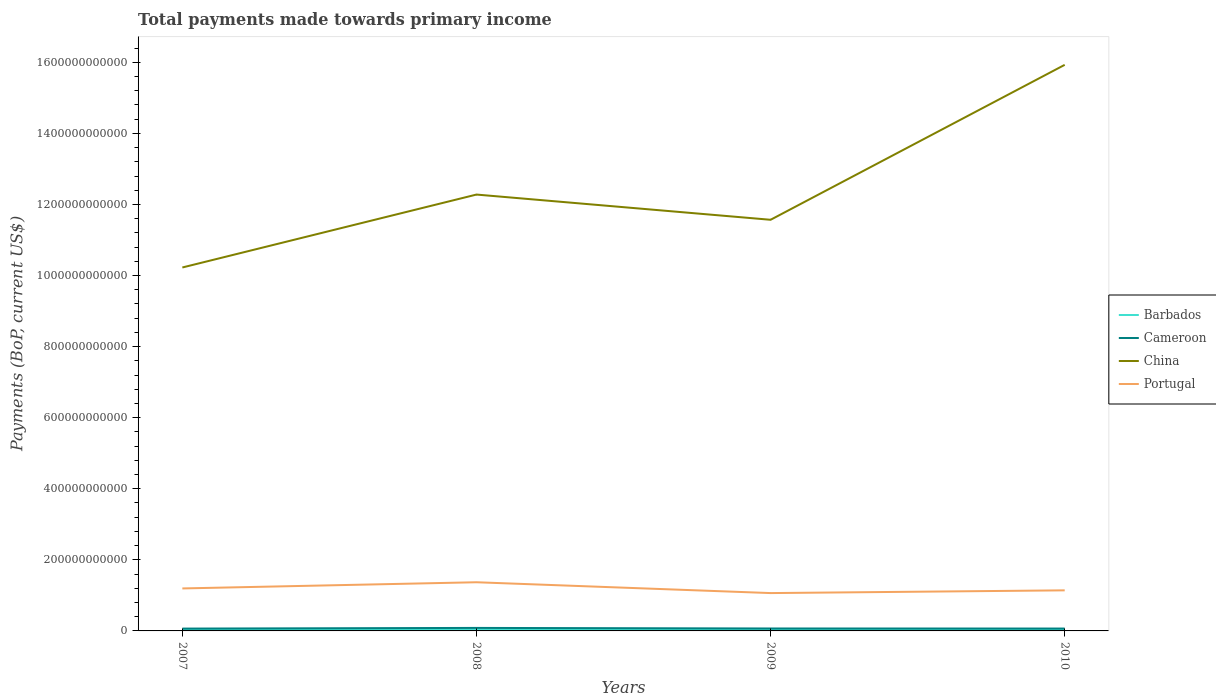How many different coloured lines are there?
Ensure brevity in your answer.  4. Across all years, what is the maximum total payments made towards primary income in Portugal?
Provide a short and direct response. 1.07e+11. In which year was the total payments made towards primary income in China maximum?
Provide a short and direct response. 2007. What is the total total payments made towards primary income in Portugal in the graph?
Provide a succinct answer. -1.74e+1. What is the difference between the highest and the second highest total payments made towards primary income in Portugal?
Give a very brief answer. 3.05e+1. Is the total payments made towards primary income in Portugal strictly greater than the total payments made towards primary income in China over the years?
Make the answer very short. Yes. How many lines are there?
Offer a very short reply. 4. What is the difference between two consecutive major ticks on the Y-axis?
Give a very brief answer. 2.00e+11. Does the graph contain grids?
Give a very brief answer. No. How many legend labels are there?
Offer a terse response. 4. How are the legend labels stacked?
Your response must be concise. Vertical. What is the title of the graph?
Give a very brief answer. Total payments made towards primary income. What is the label or title of the Y-axis?
Give a very brief answer. Payments (BoP, current US$). What is the Payments (BoP, current US$) of Barbados in 2007?
Your answer should be very brief. 2.76e+09. What is the Payments (BoP, current US$) of Cameroon in 2007?
Your answer should be compact. 6.55e+09. What is the Payments (BoP, current US$) of China in 2007?
Provide a short and direct response. 1.02e+12. What is the Payments (BoP, current US$) of Portugal in 2007?
Your response must be concise. 1.20e+11. What is the Payments (BoP, current US$) in Barbados in 2008?
Provide a succinct answer. 2.99e+09. What is the Payments (BoP, current US$) in Cameroon in 2008?
Ensure brevity in your answer.  8.44e+09. What is the Payments (BoP, current US$) of China in 2008?
Offer a terse response. 1.23e+12. What is the Payments (BoP, current US$) in Portugal in 2008?
Ensure brevity in your answer.  1.37e+11. What is the Payments (BoP, current US$) in Barbados in 2009?
Your answer should be compact. 2.54e+09. What is the Payments (BoP, current US$) in Cameroon in 2009?
Your answer should be very brief. 6.84e+09. What is the Payments (BoP, current US$) in China in 2009?
Provide a succinct answer. 1.16e+12. What is the Payments (BoP, current US$) in Portugal in 2009?
Keep it short and to the point. 1.07e+11. What is the Payments (BoP, current US$) in Barbados in 2010?
Your answer should be compact. 2.59e+09. What is the Payments (BoP, current US$) of Cameroon in 2010?
Your answer should be compact. 6.70e+09. What is the Payments (BoP, current US$) of China in 2010?
Offer a terse response. 1.59e+12. What is the Payments (BoP, current US$) in Portugal in 2010?
Provide a short and direct response. 1.14e+11. Across all years, what is the maximum Payments (BoP, current US$) in Barbados?
Offer a terse response. 2.99e+09. Across all years, what is the maximum Payments (BoP, current US$) of Cameroon?
Make the answer very short. 8.44e+09. Across all years, what is the maximum Payments (BoP, current US$) in China?
Your answer should be compact. 1.59e+12. Across all years, what is the maximum Payments (BoP, current US$) in Portugal?
Your response must be concise. 1.37e+11. Across all years, what is the minimum Payments (BoP, current US$) of Barbados?
Your response must be concise. 2.54e+09. Across all years, what is the minimum Payments (BoP, current US$) in Cameroon?
Provide a short and direct response. 6.55e+09. Across all years, what is the minimum Payments (BoP, current US$) in China?
Your answer should be very brief. 1.02e+12. Across all years, what is the minimum Payments (BoP, current US$) in Portugal?
Provide a short and direct response. 1.07e+11. What is the total Payments (BoP, current US$) in Barbados in the graph?
Make the answer very short. 1.09e+1. What is the total Payments (BoP, current US$) in Cameroon in the graph?
Make the answer very short. 2.85e+1. What is the total Payments (BoP, current US$) of China in the graph?
Provide a short and direct response. 5.00e+12. What is the total Payments (BoP, current US$) in Portugal in the graph?
Ensure brevity in your answer.  4.77e+11. What is the difference between the Payments (BoP, current US$) of Barbados in 2007 and that in 2008?
Your answer should be very brief. -2.37e+08. What is the difference between the Payments (BoP, current US$) of Cameroon in 2007 and that in 2008?
Offer a terse response. -1.89e+09. What is the difference between the Payments (BoP, current US$) of China in 2007 and that in 2008?
Make the answer very short. -2.05e+11. What is the difference between the Payments (BoP, current US$) of Portugal in 2007 and that in 2008?
Your answer should be compact. -1.74e+1. What is the difference between the Payments (BoP, current US$) of Barbados in 2007 and that in 2009?
Keep it short and to the point. 2.16e+08. What is the difference between the Payments (BoP, current US$) in Cameroon in 2007 and that in 2009?
Your answer should be compact. -2.90e+08. What is the difference between the Payments (BoP, current US$) of China in 2007 and that in 2009?
Give a very brief answer. -1.34e+11. What is the difference between the Payments (BoP, current US$) in Portugal in 2007 and that in 2009?
Your answer should be very brief. 1.31e+1. What is the difference between the Payments (BoP, current US$) of Barbados in 2007 and that in 2010?
Your answer should be compact. 1.68e+08. What is the difference between the Payments (BoP, current US$) of Cameroon in 2007 and that in 2010?
Ensure brevity in your answer.  -1.51e+08. What is the difference between the Payments (BoP, current US$) in China in 2007 and that in 2010?
Make the answer very short. -5.70e+11. What is the difference between the Payments (BoP, current US$) of Portugal in 2007 and that in 2010?
Ensure brevity in your answer.  5.39e+09. What is the difference between the Payments (BoP, current US$) in Barbados in 2008 and that in 2009?
Your answer should be very brief. 4.53e+08. What is the difference between the Payments (BoP, current US$) in Cameroon in 2008 and that in 2009?
Provide a short and direct response. 1.60e+09. What is the difference between the Payments (BoP, current US$) of China in 2008 and that in 2009?
Offer a terse response. 7.10e+1. What is the difference between the Payments (BoP, current US$) in Portugal in 2008 and that in 2009?
Keep it short and to the point. 3.05e+1. What is the difference between the Payments (BoP, current US$) of Barbados in 2008 and that in 2010?
Offer a very short reply. 4.05e+08. What is the difference between the Payments (BoP, current US$) in Cameroon in 2008 and that in 2010?
Keep it short and to the point. 1.74e+09. What is the difference between the Payments (BoP, current US$) of China in 2008 and that in 2010?
Provide a succinct answer. -3.65e+11. What is the difference between the Payments (BoP, current US$) in Portugal in 2008 and that in 2010?
Provide a short and direct response. 2.28e+1. What is the difference between the Payments (BoP, current US$) in Barbados in 2009 and that in 2010?
Make the answer very short. -4.80e+07. What is the difference between the Payments (BoP, current US$) in Cameroon in 2009 and that in 2010?
Make the answer very short. 1.39e+08. What is the difference between the Payments (BoP, current US$) in China in 2009 and that in 2010?
Give a very brief answer. -4.36e+11. What is the difference between the Payments (BoP, current US$) of Portugal in 2009 and that in 2010?
Ensure brevity in your answer.  -7.67e+09. What is the difference between the Payments (BoP, current US$) in Barbados in 2007 and the Payments (BoP, current US$) in Cameroon in 2008?
Offer a very short reply. -5.68e+09. What is the difference between the Payments (BoP, current US$) of Barbados in 2007 and the Payments (BoP, current US$) of China in 2008?
Offer a terse response. -1.23e+12. What is the difference between the Payments (BoP, current US$) of Barbados in 2007 and the Payments (BoP, current US$) of Portugal in 2008?
Your answer should be compact. -1.34e+11. What is the difference between the Payments (BoP, current US$) in Cameroon in 2007 and the Payments (BoP, current US$) in China in 2008?
Give a very brief answer. -1.22e+12. What is the difference between the Payments (BoP, current US$) in Cameroon in 2007 and the Payments (BoP, current US$) in Portugal in 2008?
Your answer should be very brief. -1.30e+11. What is the difference between the Payments (BoP, current US$) in China in 2007 and the Payments (BoP, current US$) in Portugal in 2008?
Offer a terse response. 8.86e+11. What is the difference between the Payments (BoP, current US$) in Barbados in 2007 and the Payments (BoP, current US$) in Cameroon in 2009?
Your answer should be very brief. -4.09e+09. What is the difference between the Payments (BoP, current US$) in Barbados in 2007 and the Payments (BoP, current US$) in China in 2009?
Offer a very short reply. -1.15e+12. What is the difference between the Payments (BoP, current US$) in Barbados in 2007 and the Payments (BoP, current US$) in Portugal in 2009?
Provide a succinct answer. -1.04e+11. What is the difference between the Payments (BoP, current US$) in Cameroon in 2007 and the Payments (BoP, current US$) in China in 2009?
Your answer should be compact. -1.15e+12. What is the difference between the Payments (BoP, current US$) of Cameroon in 2007 and the Payments (BoP, current US$) of Portugal in 2009?
Provide a succinct answer. -9.99e+1. What is the difference between the Payments (BoP, current US$) of China in 2007 and the Payments (BoP, current US$) of Portugal in 2009?
Provide a succinct answer. 9.16e+11. What is the difference between the Payments (BoP, current US$) in Barbados in 2007 and the Payments (BoP, current US$) in Cameroon in 2010?
Your answer should be compact. -3.95e+09. What is the difference between the Payments (BoP, current US$) in Barbados in 2007 and the Payments (BoP, current US$) in China in 2010?
Give a very brief answer. -1.59e+12. What is the difference between the Payments (BoP, current US$) in Barbados in 2007 and the Payments (BoP, current US$) in Portugal in 2010?
Make the answer very short. -1.11e+11. What is the difference between the Payments (BoP, current US$) in Cameroon in 2007 and the Payments (BoP, current US$) in China in 2010?
Offer a very short reply. -1.59e+12. What is the difference between the Payments (BoP, current US$) in Cameroon in 2007 and the Payments (BoP, current US$) in Portugal in 2010?
Provide a short and direct response. -1.08e+11. What is the difference between the Payments (BoP, current US$) of China in 2007 and the Payments (BoP, current US$) of Portugal in 2010?
Your answer should be very brief. 9.09e+11. What is the difference between the Payments (BoP, current US$) of Barbados in 2008 and the Payments (BoP, current US$) of Cameroon in 2009?
Offer a very short reply. -3.85e+09. What is the difference between the Payments (BoP, current US$) of Barbados in 2008 and the Payments (BoP, current US$) of China in 2009?
Your response must be concise. -1.15e+12. What is the difference between the Payments (BoP, current US$) of Barbados in 2008 and the Payments (BoP, current US$) of Portugal in 2009?
Make the answer very short. -1.04e+11. What is the difference between the Payments (BoP, current US$) in Cameroon in 2008 and the Payments (BoP, current US$) in China in 2009?
Provide a short and direct response. -1.15e+12. What is the difference between the Payments (BoP, current US$) in Cameroon in 2008 and the Payments (BoP, current US$) in Portugal in 2009?
Keep it short and to the point. -9.81e+1. What is the difference between the Payments (BoP, current US$) of China in 2008 and the Payments (BoP, current US$) of Portugal in 2009?
Make the answer very short. 1.12e+12. What is the difference between the Payments (BoP, current US$) in Barbados in 2008 and the Payments (BoP, current US$) in Cameroon in 2010?
Offer a very short reply. -3.71e+09. What is the difference between the Payments (BoP, current US$) of Barbados in 2008 and the Payments (BoP, current US$) of China in 2010?
Provide a succinct answer. -1.59e+12. What is the difference between the Payments (BoP, current US$) of Barbados in 2008 and the Payments (BoP, current US$) of Portugal in 2010?
Provide a succinct answer. -1.11e+11. What is the difference between the Payments (BoP, current US$) of Cameroon in 2008 and the Payments (BoP, current US$) of China in 2010?
Provide a short and direct response. -1.58e+12. What is the difference between the Payments (BoP, current US$) of Cameroon in 2008 and the Payments (BoP, current US$) of Portugal in 2010?
Your answer should be very brief. -1.06e+11. What is the difference between the Payments (BoP, current US$) in China in 2008 and the Payments (BoP, current US$) in Portugal in 2010?
Make the answer very short. 1.11e+12. What is the difference between the Payments (BoP, current US$) of Barbados in 2009 and the Payments (BoP, current US$) of Cameroon in 2010?
Provide a succinct answer. -4.16e+09. What is the difference between the Payments (BoP, current US$) of Barbados in 2009 and the Payments (BoP, current US$) of China in 2010?
Your response must be concise. -1.59e+12. What is the difference between the Payments (BoP, current US$) in Barbados in 2009 and the Payments (BoP, current US$) in Portugal in 2010?
Your answer should be compact. -1.12e+11. What is the difference between the Payments (BoP, current US$) of Cameroon in 2009 and the Payments (BoP, current US$) of China in 2010?
Provide a succinct answer. -1.59e+12. What is the difference between the Payments (BoP, current US$) of Cameroon in 2009 and the Payments (BoP, current US$) of Portugal in 2010?
Provide a short and direct response. -1.07e+11. What is the difference between the Payments (BoP, current US$) of China in 2009 and the Payments (BoP, current US$) of Portugal in 2010?
Your response must be concise. 1.04e+12. What is the average Payments (BoP, current US$) of Barbados per year?
Provide a succinct answer. 2.72e+09. What is the average Payments (BoP, current US$) of Cameroon per year?
Ensure brevity in your answer.  7.13e+09. What is the average Payments (BoP, current US$) in China per year?
Your answer should be compact. 1.25e+12. What is the average Payments (BoP, current US$) of Portugal per year?
Your answer should be very brief. 1.19e+11. In the year 2007, what is the difference between the Payments (BoP, current US$) in Barbados and Payments (BoP, current US$) in Cameroon?
Provide a short and direct response. -3.80e+09. In the year 2007, what is the difference between the Payments (BoP, current US$) of Barbados and Payments (BoP, current US$) of China?
Give a very brief answer. -1.02e+12. In the year 2007, what is the difference between the Payments (BoP, current US$) in Barbados and Payments (BoP, current US$) in Portugal?
Offer a terse response. -1.17e+11. In the year 2007, what is the difference between the Payments (BoP, current US$) in Cameroon and Payments (BoP, current US$) in China?
Your answer should be very brief. -1.02e+12. In the year 2007, what is the difference between the Payments (BoP, current US$) of Cameroon and Payments (BoP, current US$) of Portugal?
Your answer should be very brief. -1.13e+11. In the year 2007, what is the difference between the Payments (BoP, current US$) in China and Payments (BoP, current US$) in Portugal?
Your response must be concise. 9.03e+11. In the year 2008, what is the difference between the Payments (BoP, current US$) of Barbados and Payments (BoP, current US$) of Cameroon?
Offer a very short reply. -5.45e+09. In the year 2008, what is the difference between the Payments (BoP, current US$) of Barbados and Payments (BoP, current US$) of China?
Provide a succinct answer. -1.22e+12. In the year 2008, what is the difference between the Payments (BoP, current US$) in Barbados and Payments (BoP, current US$) in Portugal?
Make the answer very short. -1.34e+11. In the year 2008, what is the difference between the Payments (BoP, current US$) of Cameroon and Payments (BoP, current US$) of China?
Ensure brevity in your answer.  -1.22e+12. In the year 2008, what is the difference between the Payments (BoP, current US$) in Cameroon and Payments (BoP, current US$) in Portugal?
Offer a very short reply. -1.29e+11. In the year 2008, what is the difference between the Payments (BoP, current US$) of China and Payments (BoP, current US$) of Portugal?
Your response must be concise. 1.09e+12. In the year 2009, what is the difference between the Payments (BoP, current US$) in Barbados and Payments (BoP, current US$) in Cameroon?
Provide a succinct answer. -4.30e+09. In the year 2009, what is the difference between the Payments (BoP, current US$) in Barbados and Payments (BoP, current US$) in China?
Give a very brief answer. -1.15e+12. In the year 2009, what is the difference between the Payments (BoP, current US$) in Barbados and Payments (BoP, current US$) in Portugal?
Offer a very short reply. -1.04e+11. In the year 2009, what is the difference between the Payments (BoP, current US$) in Cameroon and Payments (BoP, current US$) in China?
Keep it short and to the point. -1.15e+12. In the year 2009, what is the difference between the Payments (BoP, current US$) in Cameroon and Payments (BoP, current US$) in Portugal?
Offer a very short reply. -9.97e+1. In the year 2009, what is the difference between the Payments (BoP, current US$) in China and Payments (BoP, current US$) in Portugal?
Provide a succinct answer. 1.05e+12. In the year 2010, what is the difference between the Payments (BoP, current US$) of Barbados and Payments (BoP, current US$) of Cameroon?
Offer a terse response. -4.11e+09. In the year 2010, what is the difference between the Payments (BoP, current US$) of Barbados and Payments (BoP, current US$) of China?
Your answer should be compact. -1.59e+12. In the year 2010, what is the difference between the Payments (BoP, current US$) of Barbados and Payments (BoP, current US$) of Portugal?
Offer a very short reply. -1.12e+11. In the year 2010, what is the difference between the Payments (BoP, current US$) in Cameroon and Payments (BoP, current US$) in China?
Give a very brief answer. -1.59e+12. In the year 2010, what is the difference between the Payments (BoP, current US$) in Cameroon and Payments (BoP, current US$) in Portugal?
Your answer should be compact. -1.07e+11. In the year 2010, what is the difference between the Payments (BoP, current US$) in China and Payments (BoP, current US$) in Portugal?
Your response must be concise. 1.48e+12. What is the ratio of the Payments (BoP, current US$) of Barbados in 2007 to that in 2008?
Give a very brief answer. 0.92. What is the ratio of the Payments (BoP, current US$) of Cameroon in 2007 to that in 2008?
Make the answer very short. 0.78. What is the ratio of the Payments (BoP, current US$) in China in 2007 to that in 2008?
Provide a succinct answer. 0.83. What is the ratio of the Payments (BoP, current US$) in Portugal in 2007 to that in 2008?
Provide a succinct answer. 0.87. What is the ratio of the Payments (BoP, current US$) in Barbados in 2007 to that in 2009?
Ensure brevity in your answer.  1.08. What is the ratio of the Payments (BoP, current US$) in Cameroon in 2007 to that in 2009?
Your response must be concise. 0.96. What is the ratio of the Payments (BoP, current US$) in China in 2007 to that in 2009?
Your answer should be very brief. 0.88. What is the ratio of the Payments (BoP, current US$) in Portugal in 2007 to that in 2009?
Your answer should be very brief. 1.12. What is the ratio of the Payments (BoP, current US$) of Barbados in 2007 to that in 2010?
Offer a very short reply. 1.06. What is the ratio of the Payments (BoP, current US$) of Cameroon in 2007 to that in 2010?
Offer a very short reply. 0.98. What is the ratio of the Payments (BoP, current US$) in China in 2007 to that in 2010?
Provide a short and direct response. 0.64. What is the ratio of the Payments (BoP, current US$) in Portugal in 2007 to that in 2010?
Provide a short and direct response. 1.05. What is the ratio of the Payments (BoP, current US$) in Barbados in 2008 to that in 2009?
Provide a succinct answer. 1.18. What is the ratio of the Payments (BoP, current US$) in Cameroon in 2008 to that in 2009?
Your response must be concise. 1.23. What is the ratio of the Payments (BoP, current US$) of China in 2008 to that in 2009?
Provide a short and direct response. 1.06. What is the ratio of the Payments (BoP, current US$) in Portugal in 2008 to that in 2009?
Offer a terse response. 1.29. What is the ratio of the Payments (BoP, current US$) in Barbados in 2008 to that in 2010?
Offer a terse response. 1.16. What is the ratio of the Payments (BoP, current US$) of Cameroon in 2008 to that in 2010?
Make the answer very short. 1.26. What is the ratio of the Payments (BoP, current US$) of China in 2008 to that in 2010?
Your answer should be very brief. 0.77. What is the ratio of the Payments (BoP, current US$) in Portugal in 2008 to that in 2010?
Offer a very short reply. 1.2. What is the ratio of the Payments (BoP, current US$) in Barbados in 2009 to that in 2010?
Make the answer very short. 0.98. What is the ratio of the Payments (BoP, current US$) of Cameroon in 2009 to that in 2010?
Ensure brevity in your answer.  1.02. What is the ratio of the Payments (BoP, current US$) in China in 2009 to that in 2010?
Provide a succinct answer. 0.73. What is the ratio of the Payments (BoP, current US$) in Portugal in 2009 to that in 2010?
Give a very brief answer. 0.93. What is the difference between the highest and the second highest Payments (BoP, current US$) in Barbados?
Give a very brief answer. 2.37e+08. What is the difference between the highest and the second highest Payments (BoP, current US$) in Cameroon?
Your answer should be very brief. 1.60e+09. What is the difference between the highest and the second highest Payments (BoP, current US$) in China?
Provide a short and direct response. 3.65e+11. What is the difference between the highest and the second highest Payments (BoP, current US$) in Portugal?
Your answer should be compact. 1.74e+1. What is the difference between the highest and the lowest Payments (BoP, current US$) of Barbados?
Keep it short and to the point. 4.53e+08. What is the difference between the highest and the lowest Payments (BoP, current US$) of Cameroon?
Keep it short and to the point. 1.89e+09. What is the difference between the highest and the lowest Payments (BoP, current US$) of China?
Your answer should be compact. 5.70e+11. What is the difference between the highest and the lowest Payments (BoP, current US$) of Portugal?
Your answer should be very brief. 3.05e+1. 